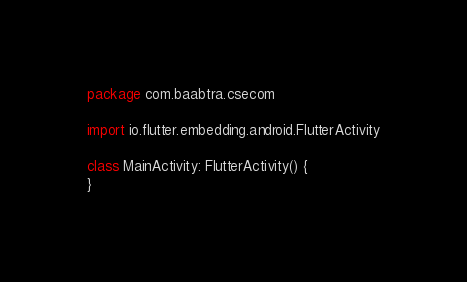Convert code to text. <code><loc_0><loc_0><loc_500><loc_500><_Kotlin_>package com.baabtra.csecom

import io.flutter.embedding.android.FlutterActivity

class MainActivity: FlutterActivity() {
}
</code> 